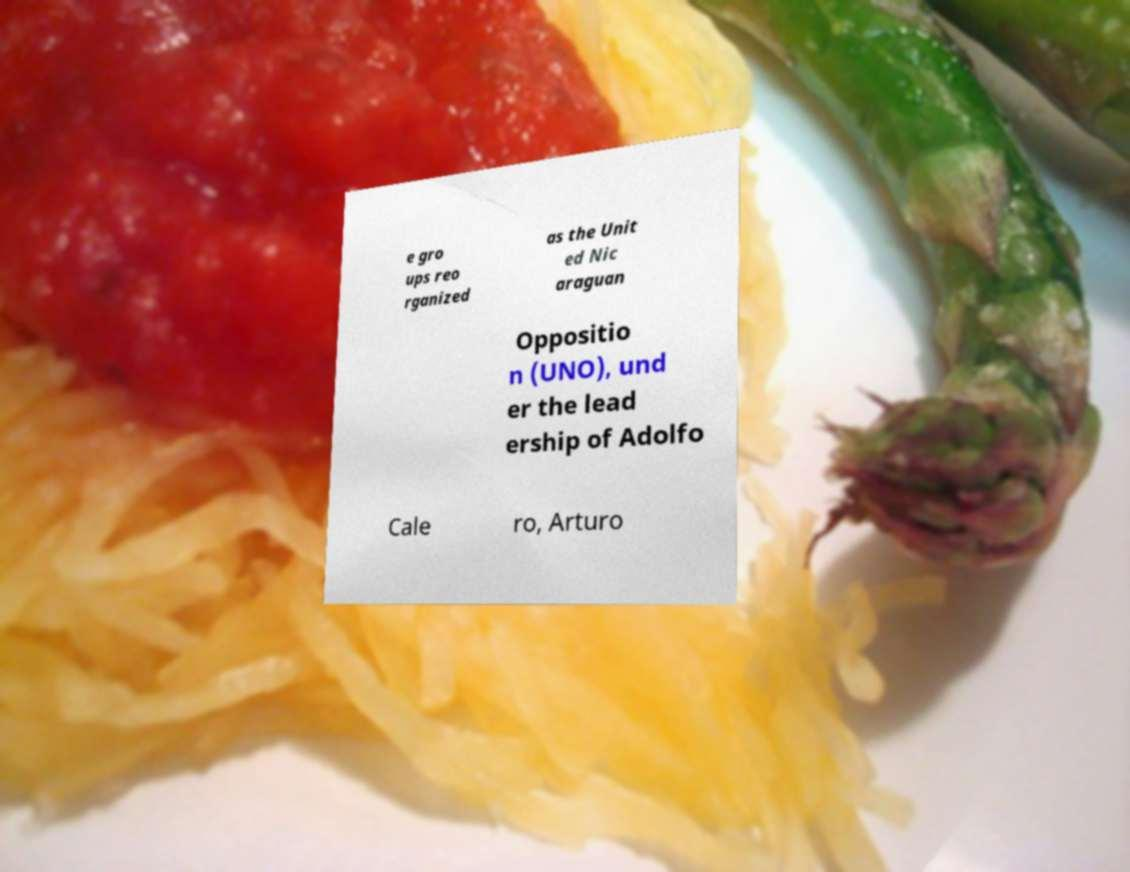What messages or text are displayed in this image? I need them in a readable, typed format. e gro ups reo rganized as the Unit ed Nic araguan Oppositio n (UNO), und er the lead ership of Adolfo Cale ro, Arturo 